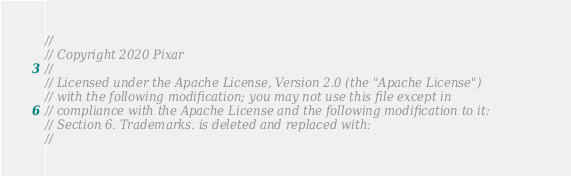<code> <loc_0><loc_0><loc_500><loc_500><_ObjectiveC_>//
// Copyright 2020 Pixar
//
// Licensed under the Apache License, Version 2.0 (the "Apache License")
// with the following modification; you may not use this file except in
// compliance with the Apache License and the following modification to it:
// Section 6. Trademarks. is deleted and replaced with:
//</code> 